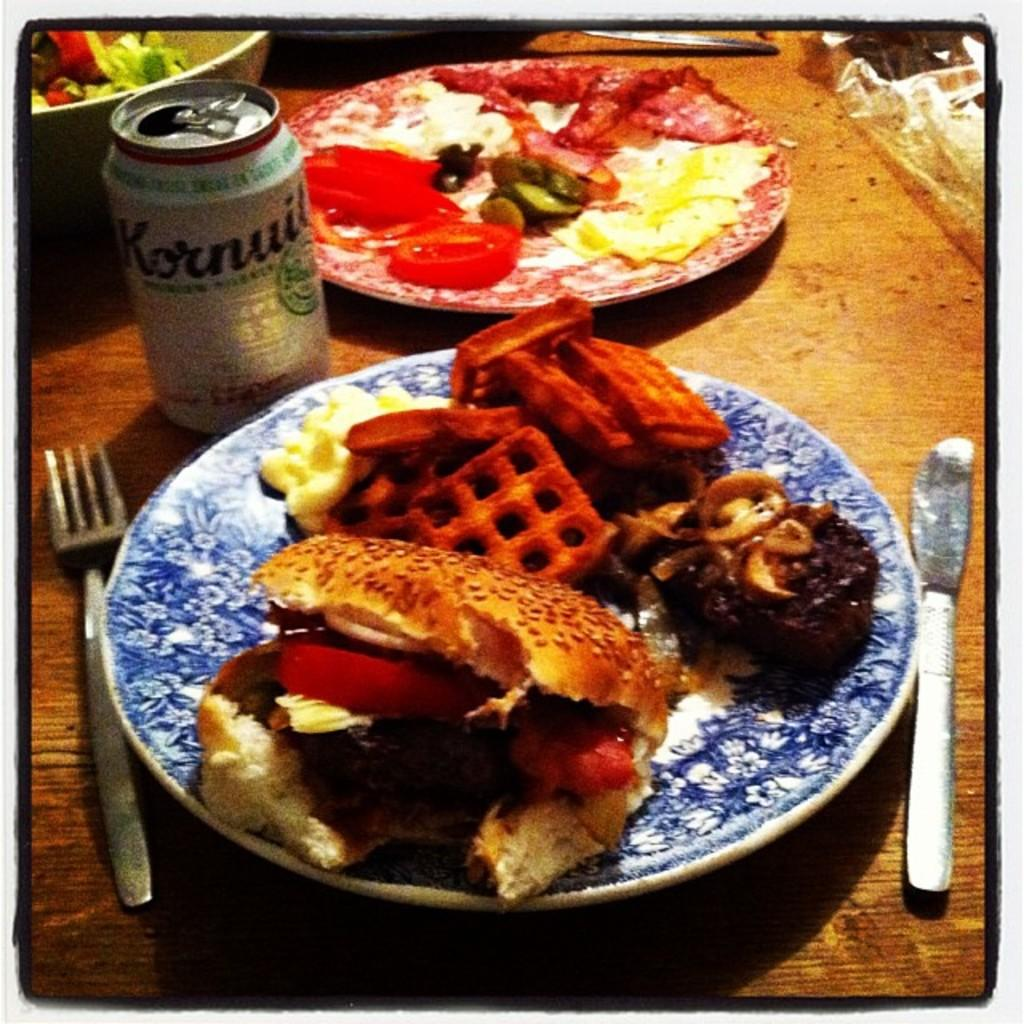What can be seen on the plates in the image? There are food items in two different plates in the image. What else can be seen in the image besides the plates? There is a bowl with food items, a tin, a fork, and a butter knife on the wooden surface in the image. What is the material of the surface where the food items are placed? The wooden surface is where the food items, tin, fork, and butter knife are placed. Are there any borders visible in the image? Yes, the image has borders. How many ladybugs can be seen on the food items in the image? There are no ladybugs present in the image; it only features food items, plates, a bowl, a tin, a fork, a butter knife, and a wooden surface. 